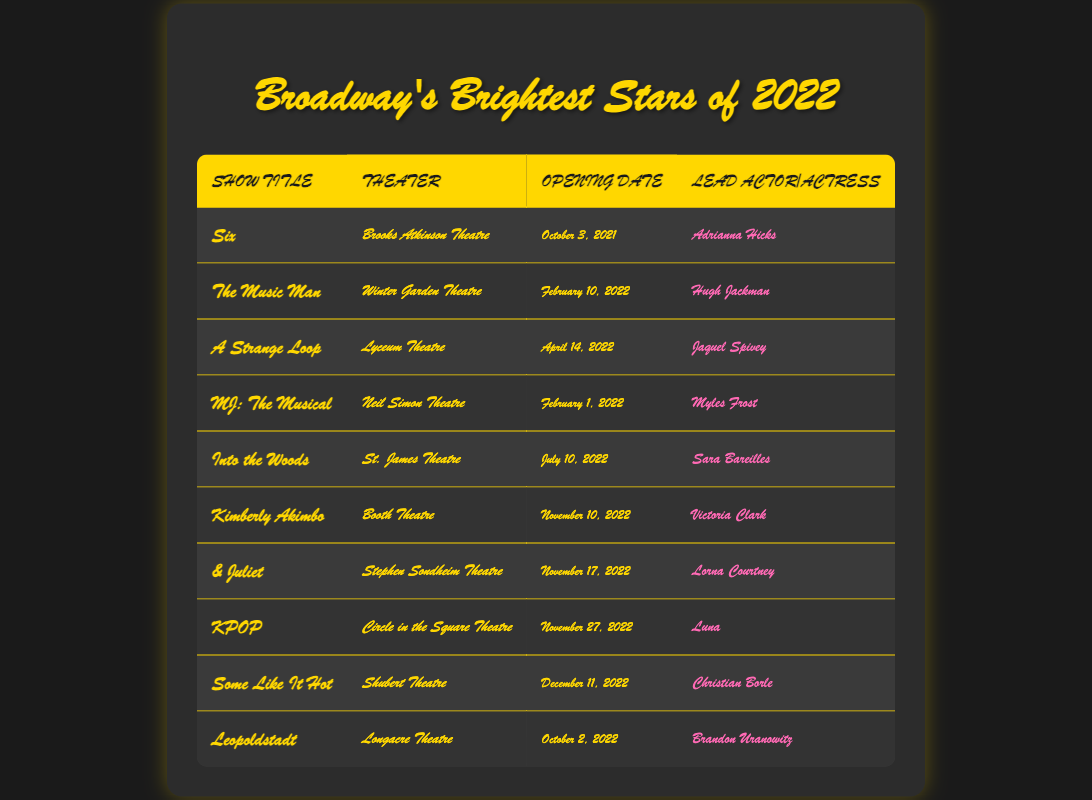What is the title of the show that opened on February 10, 2022? By looking at the opening dates in the table, I can see that "The Music Man" is listed as opening on February 10, 2022.
Answer: The Music Man Which theater hosted "MJ: The Musical"? The table shows that "MJ: The Musical" was performed at the Neil Simon Theatre.
Answer: Neil Simon Theatre Which show had the lead actor Myles Frost? Referring to the table, I find that Myles Frost is listed as the lead actor for "MJ: The Musical."
Answer: MJ: The Musical How many shows opened in November 2022? In November 2022, both "Kimberly Akimbo" (November 10) and "& Juliet" (November 17) opened, totaling two shows.
Answer: 2 Is "Into the Woods" performed at the Longacre Theatre? "Into the Woods" is listed as being performed at the St. James Theatre, not the Longacre Theatre. So this statement is false.
Answer: No Which show opened last in 2022 and what was its lead actor? According to the table, "Some Like It Hot" opened on December 11, 2022, featuring Christian Borle as the lead actor.
Answer: Some Like It Hot, Christian Borle Was there a show with an opening date in April 2022? Looking at the opening dates, I see that "A Strange Loop" opened on April 14, 2022. This confirms that there was at least one show opening in that month.
Answer: Yes Who opened the last Broadway show of 2022 and which theater was it performed in? "Some Like It Hot," which opened on December 11, 2022, was the last show of the year, and it was performed at the Shubert Theatre.
Answer: Some Like It Hot, Shubert Theatre Which show had the latest opening date in the provided data? Reviewing the opening dates, the latest one is for "Some Like It Hot," which opened on December 11, 2022.
Answer: Some Like It Hot 